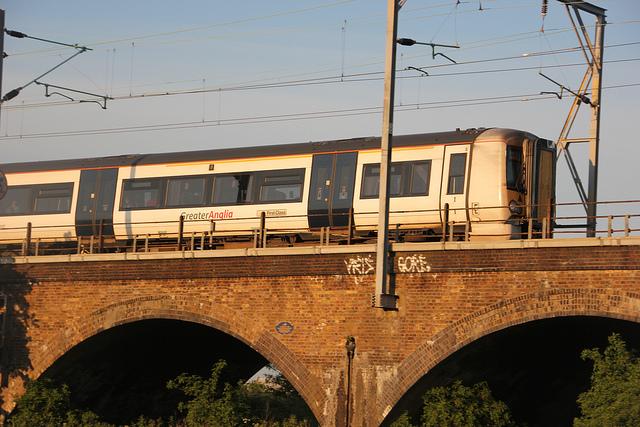Are the train windows open?
Be succinct. No. Is this a brand new bridge?
Quick response, please. No. Is there graffiti on the bridge?
Keep it brief. Yes. 